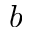<formula> <loc_0><loc_0><loc_500><loc_500>b</formula> 